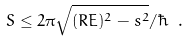Convert formula to latex. <formula><loc_0><loc_0><loc_500><loc_500>S \leq 2 \pi \sqrt { ( R E ) ^ { 2 } - s ^ { 2 } } / \hbar { \ } .</formula> 